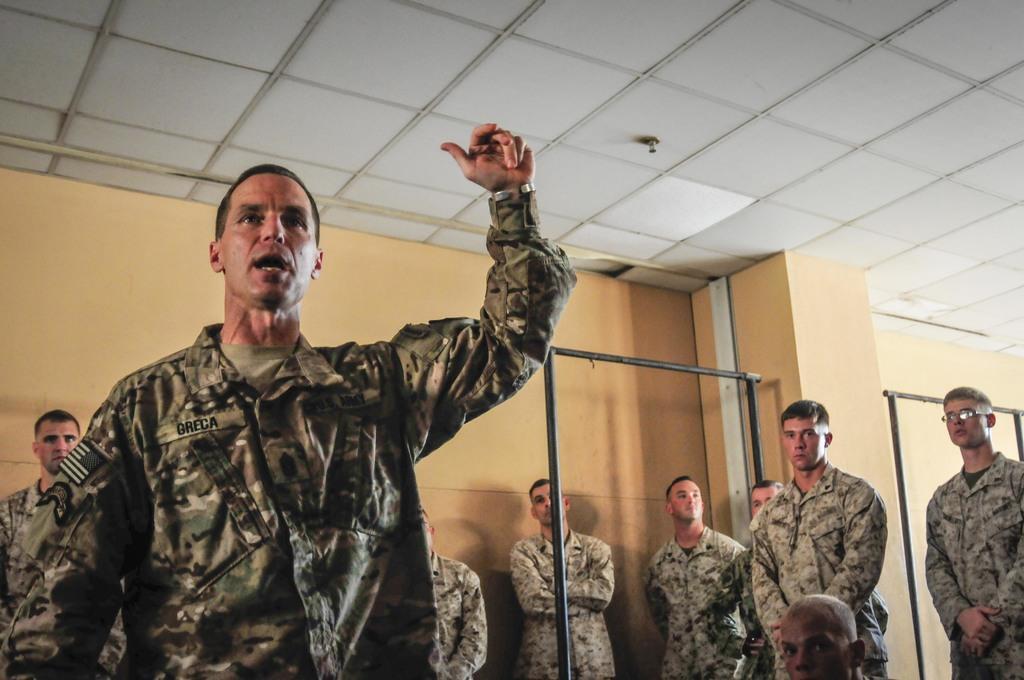Describe this image in one or two sentences. In this image I can see the group of people with military uniforms. In the background I can see the iron rods and the wall. 